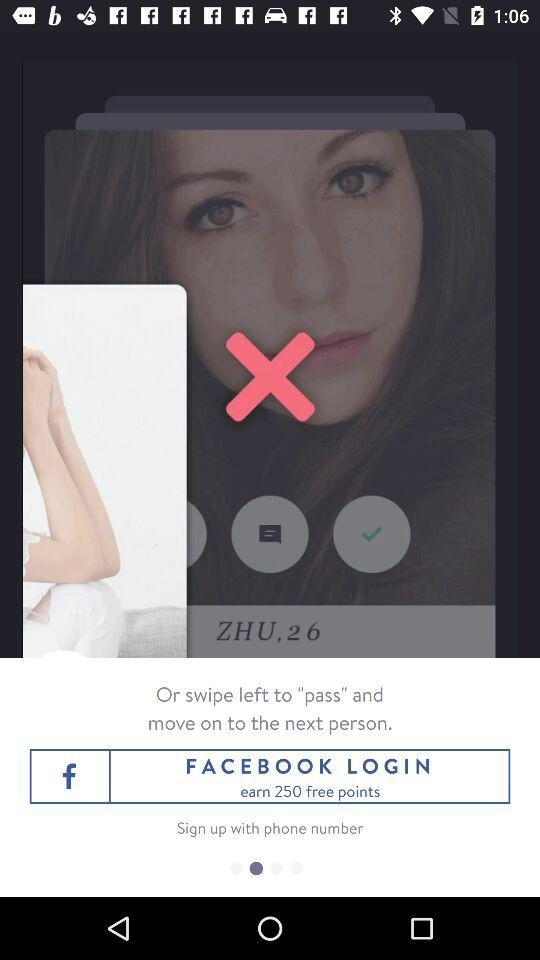How many free points can we earn? You can earn 250 free points. 